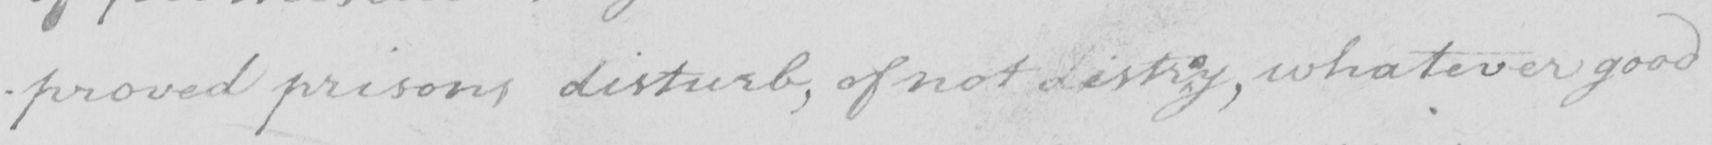Can you read and transcribe this handwriting? -proved prisons disturb , of not distr y , whatever good 